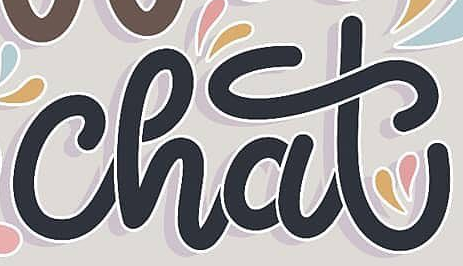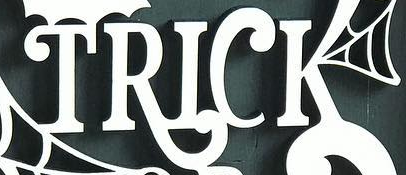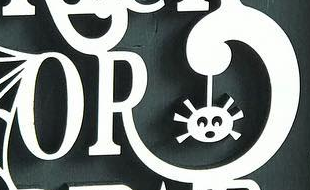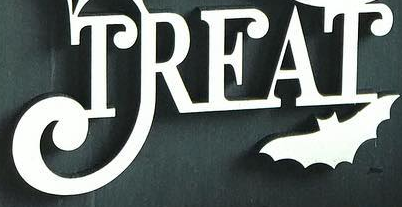What words are shown in these images in order, separated by a semicolon? chat; TRICK; OR; TREAT 